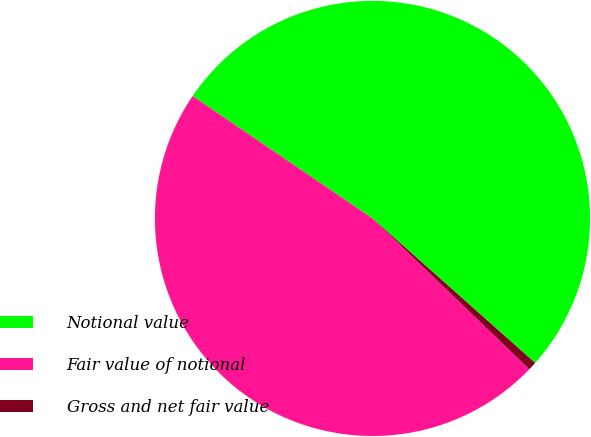<chart> <loc_0><loc_0><loc_500><loc_500><pie_chart><fcel>Notional value<fcel>Fair value of notional<fcel>Gross and net fair value<nl><fcel>52.05%<fcel>47.32%<fcel>0.63%<nl></chart> 